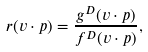<formula> <loc_0><loc_0><loc_500><loc_500>r ( v \cdot p ) = \frac { g ^ { D } ( v \cdot p ) } { f ^ { D } ( v \cdot p ) } ,</formula> 